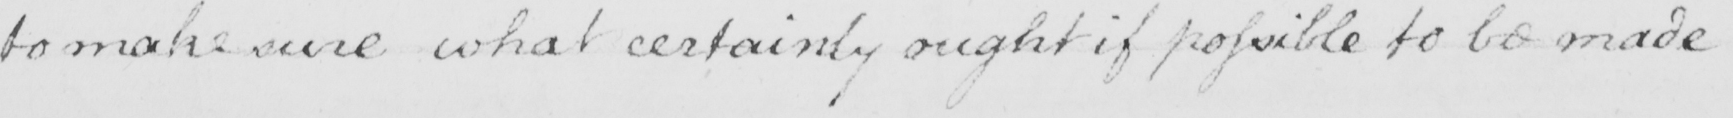Can you tell me what this handwritten text says? to make sure what certainly ought if possible to be made 